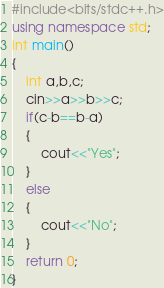Convert code to text. <code><loc_0><loc_0><loc_500><loc_500><_C++_>#include<bits/stdc++.h>
using namespace std;
int main()
{
	int a,b,c;
	cin>>a>>b>>c;
	if(c-b==b-a)
	{
		cout<<"Yes";
	}
	else
	{
		cout<<"No";
	}
	return 0;
}</code> 